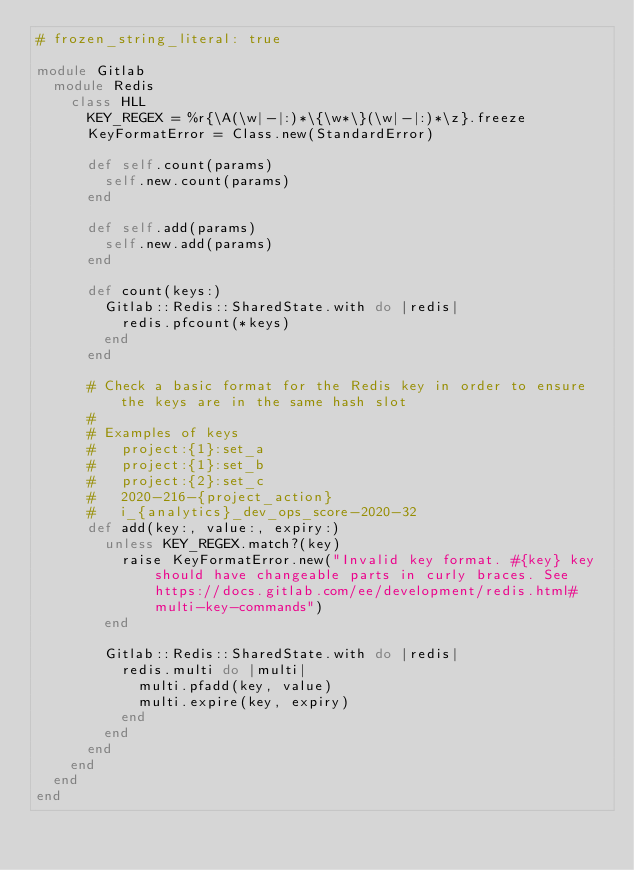<code> <loc_0><loc_0><loc_500><loc_500><_Ruby_># frozen_string_literal: true

module Gitlab
  module Redis
    class HLL
      KEY_REGEX = %r{\A(\w|-|:)*\{\w*\}(\w|-|:)*\z}.freeze
      KeyFormatError = Class.new(StandardError)

      def self.count(params)
        self.new.count(params)
      end

      def self.add(params)
        self.new.add(params)
      end

      def count(keys:)
        Gitlab::Redis::SharedState.with do |redis|
          redis.pfcount(*keys)
        end
      end

      # Check a basic format for the Redis key in order to ensure the keys are in the same hash slot
      #
      # Examples of keys
      #   project:{1}:set_a
      #   project:{1}:set_b
      #   project:{2}:set_c
      #   2020-216-{project_action}
      #   i_{analytics}_dev_ops_score-2020-32
      def add(key:, value:, expiry:)
        unless KEY_REGEX.match?(key)
          raise KeyFormatError.new("Invalid key format. #{key} key should have changeable parts in curly braces. See https://docs.gitlab.com/ee/development/redis.html#multi-key-commands")
        end

        Gitlab::Redis::SharedState.with do |redis|
          redis.multi do |multi|
            multi.pfadd(key, value)
            multi.expire(key, expiry)
          end
        end
      end
    end
  end
end
</code> 